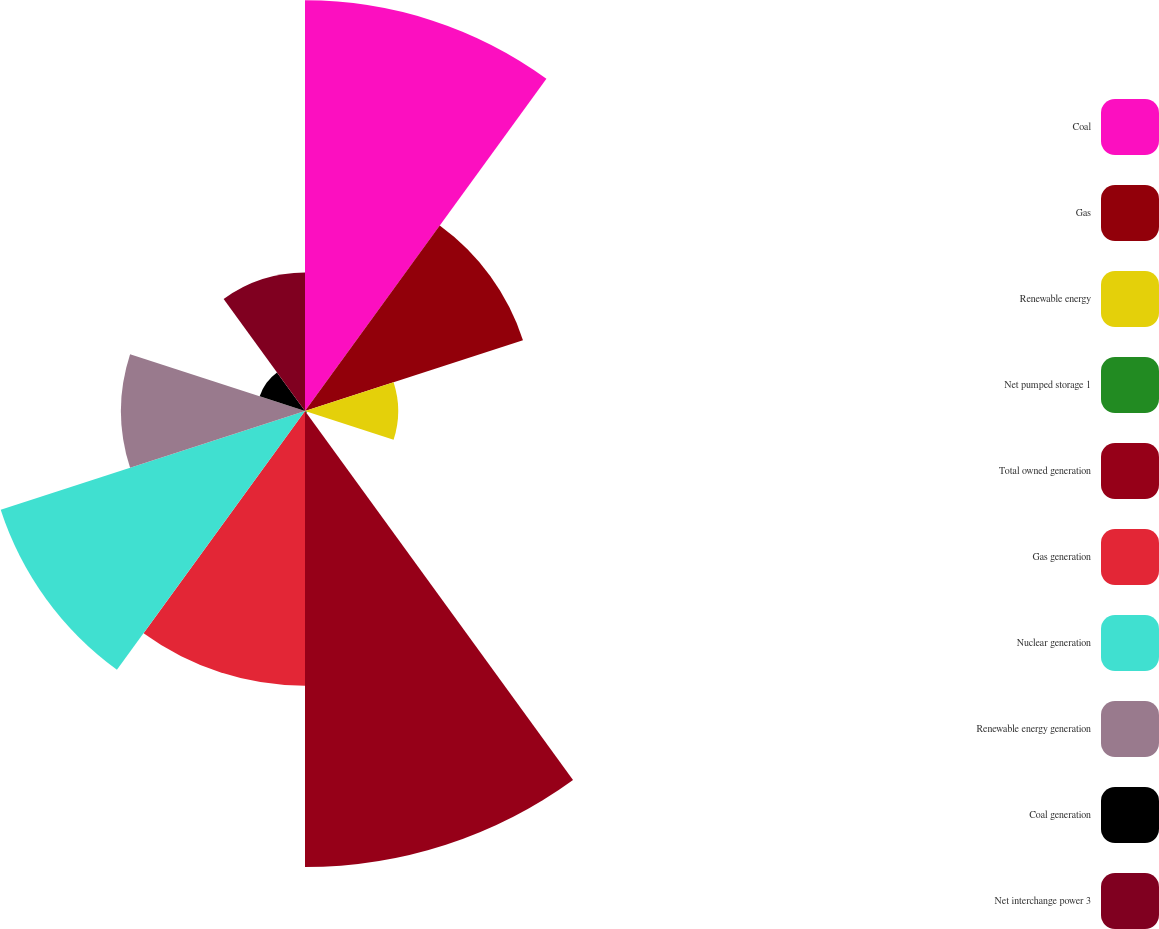Convert chart. <chart><loc_0><loc_0><loc_500><loc_500><pie_chart><fcel>Coal<fcel>Gas<fcel>Renewable energy<fcel>Net pumped storage 1<fcel>Total owned generation<fcel>Gas generation<fcel>Nuclear generation<fcel>Renewable energy generation<fcel>Coal generation<fcel>Net interchange power 3<nl><fcel>19.05%<fcel>10.63%<fcel>4.32%<fcel>0.11%<fcel>21.15%<fcel>12.74%<fcel>14.84%<fcel>8.53%<fcel>2.21%<fcel>6.42%<nl></chart> 